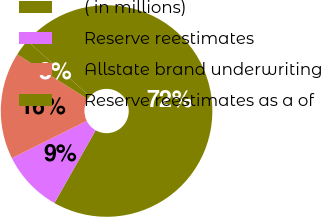<chart> <loc_0><loc_0><loc_500><loc_500><pie_chart><fcel>( in millions)<fcel>Reserve reestimates<fcel>Allstate brand underwriting<fcel>Reserve reestimates as a of<nl><fcel>71.7%<fcel>9.43%<fcel>16.35%<fcel>2.52%<nl></chart> 